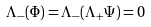<formula> <loc_0><loc_0><loc_500><loc_500>\Lambda _ { - } ( \Phi ) = \Lambda _ { - } ( \Lambda _ { + } \Psi ) = 0</formula> 